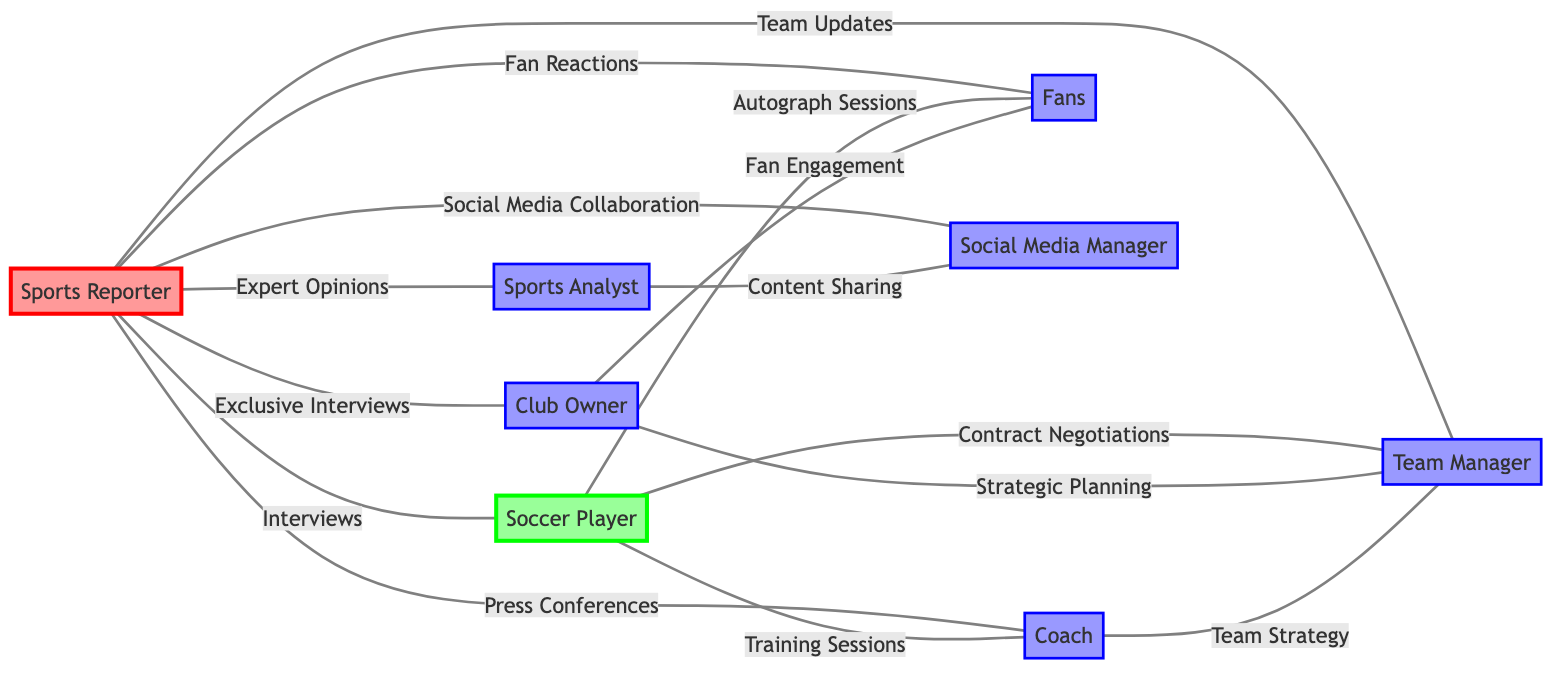What is the total number of nodes in the diagram? The diagram includes nodes for Sports Reporter, Soccer Player, Coach, Sports Analyst, Team Manager, Fans, Club Owner, and Social Media Manager. Counting these nodes gives a total of 8.
Answer: 8 Which two nodes are connected by the relationship "Exclusive Interviews"? "Exclusive Interviews" is the relationship that connects Sports Reporter and Club Owner, as seen in the edges section of the diagram.
Answer: Sports Reporter and Club Owner How many edges are connected to the Soccer Player? The Soccer Player is connected to Coach via "Training Sessions," Team Manager via "Contract Negotiations," and Fans via "Autograph Sessions," totaling 3 edges.
Answer: 3 What type of relationship exists between Sports Analyst and Social Media Manager? The relationship between Sports Analyst and Social Media Manager is labeled as "Content Sharing," which is directly stated in the edges section of the diagram.
Answer: Content Sharing Which key sports personality does the Sports Reporter engage with for "Team Updates"? The Sports Reporter engages with the Team Manager for "Team Updates," as indicated in the edges section of the diagram.
Answer: Team Manager What is the primary interaction between Club Owner and Fans? The primary interaction between Club Owner and Fans is based on "Fan Engagement," as outlined in the edges of the diagram.
Answer: Fan Engagement How many total relationships (edges) are depicted in the graph? By counting the edges listed in the diagram, there are 14 relationships connecting various nodes.
Answer: 14 What role does the Coach play in relation to the Team Manager? The role of the Coach in relation to the Team Manager is based on the relationship "Team Strategy," indicating they work closely on strategic matters.
Answer: Team Strategy Which entity is the Sports Reporter most directly connected to? The Sports Reporter is connected to multiple entities, but the first interaction listed is "Interviews" with the Soccer Player, indicating it is most direct.
Answer: Soccer Player 